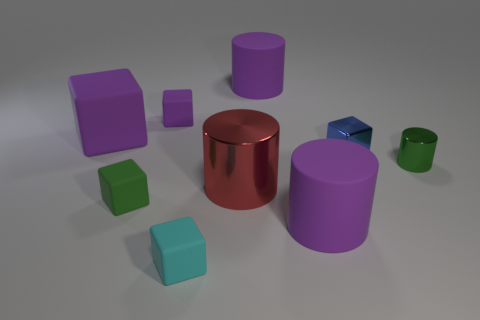Subtract all metal blocks. How many blocks are left? 4 Subtract all blue blocks. How many blocks are left? 4 Add 1 small green blocks. How many objects exist? 10 Subtract all gray cubes. Subtract all yellow spheres. How many cubes are left? 5 Subtract all cylinders. How many objects are left? 5 Add 5 small metallic cylinders. How many small metallic cylinders are left? 6 Add 3 small red metallic spheres. How many small red metallic spheres exist? 3 Subtract 0 purple balls. How many objects are left? 9 Subtract all large objects. Subtract all green metal cylinders. How many objects are left? 4 